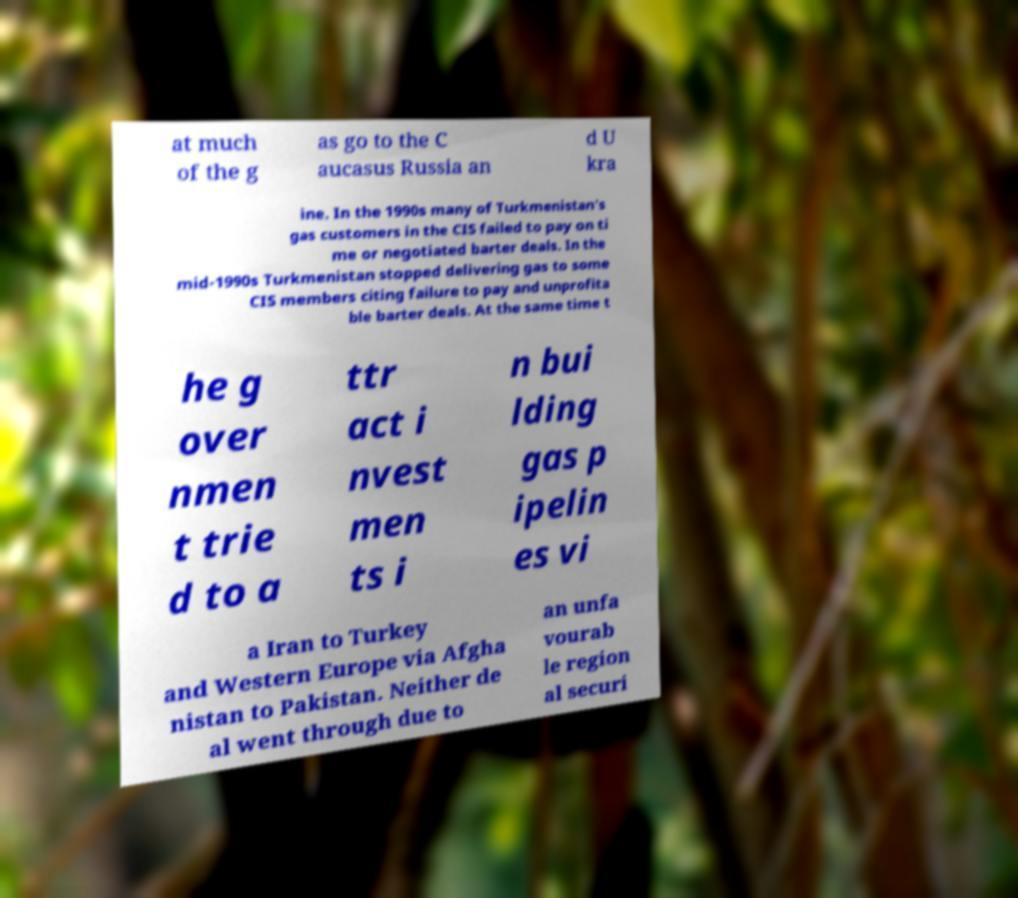Please read and relay the text visible in this image. What does it say? at much of the g as go to the C aucasus Russia an d U kra ine. In the 1990s many of Turkmenistan's gas customers in the CIS failed to pay on ti me or negotiated barter deals. In the mid-1990s Turkmenistan stopped delivering gas to some CIS members citing failure to pay and unprofita ble barter deals. At the same time t he g over nmen t trie d to a ttr act i nvest men ts i n bui lding gas p ipelin es vi a Iran to Turkey and Western Europe via Afgha nistan to Pakistan. Neither de al went through due to an unfa vourab le region al securi 